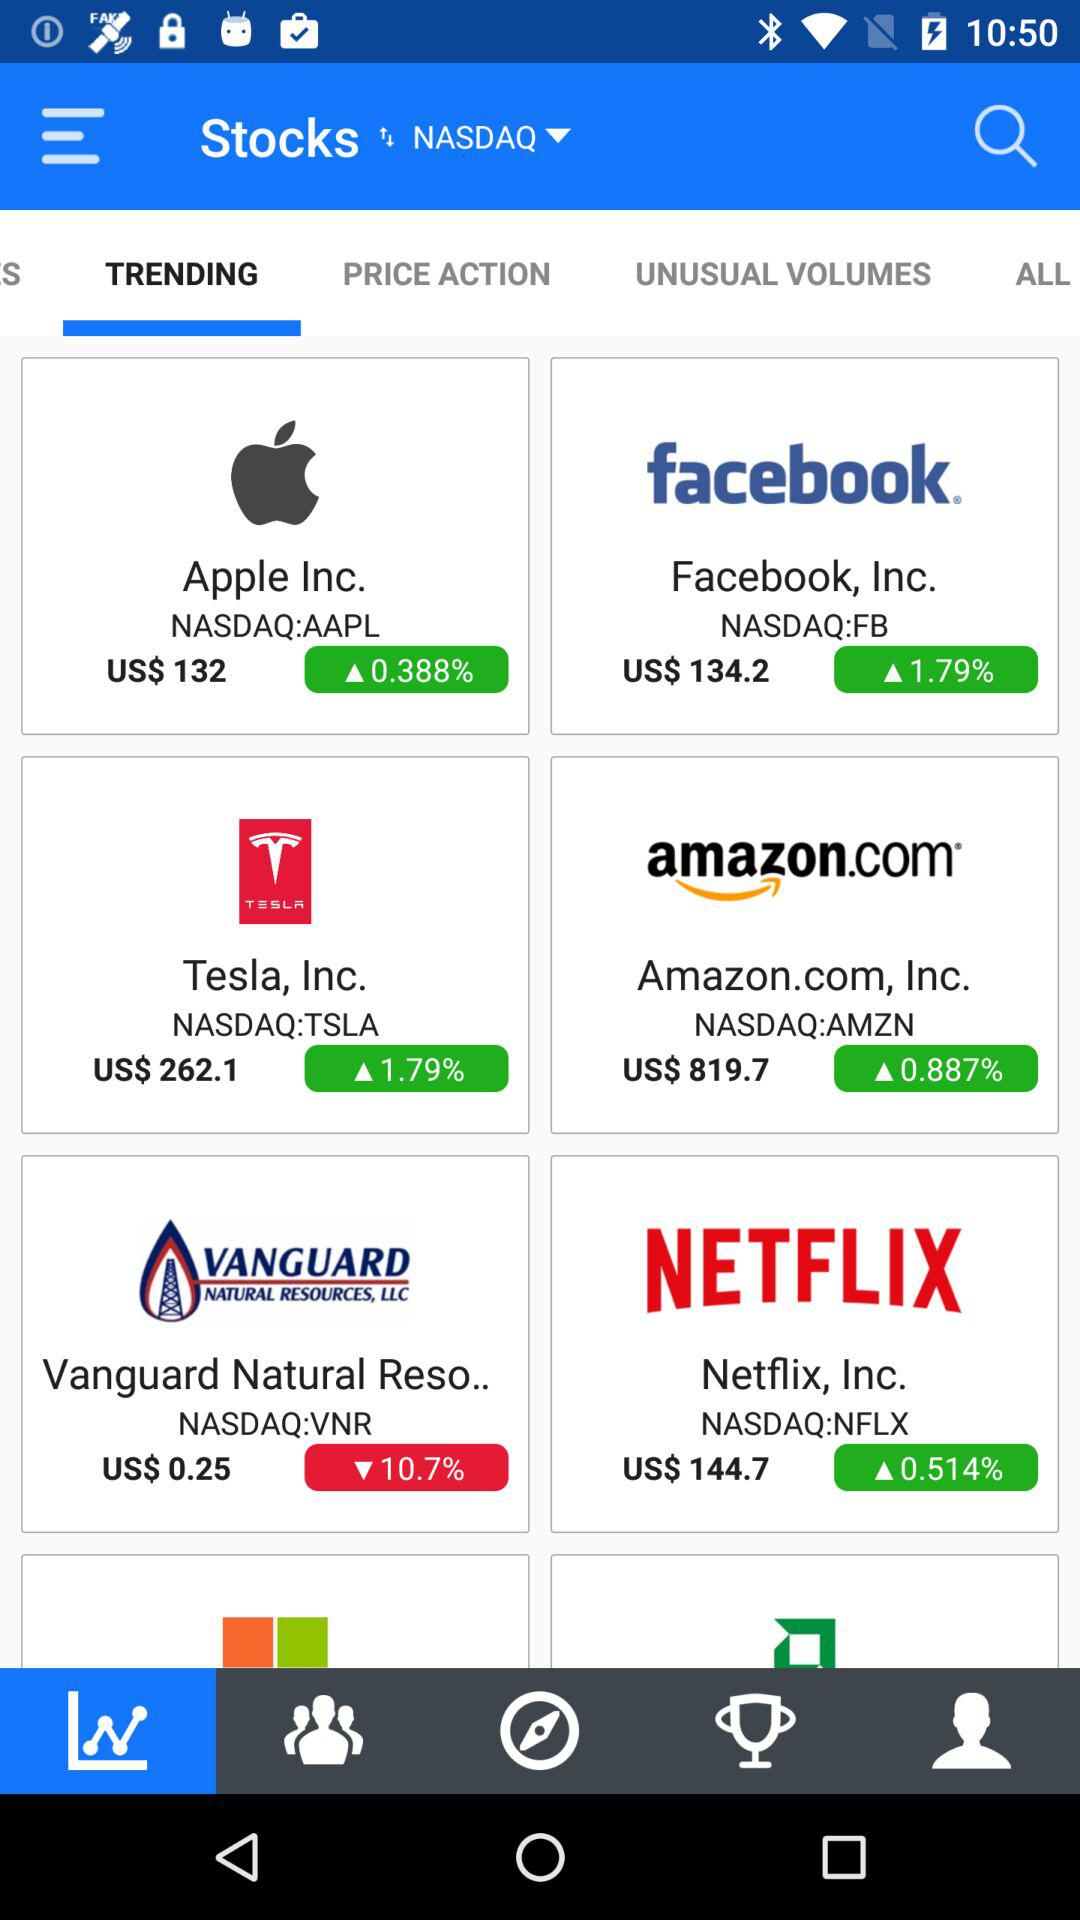What is the price of the "NETFLIX" stock? The price of the "NETFLIX" stock is US $144.7. 